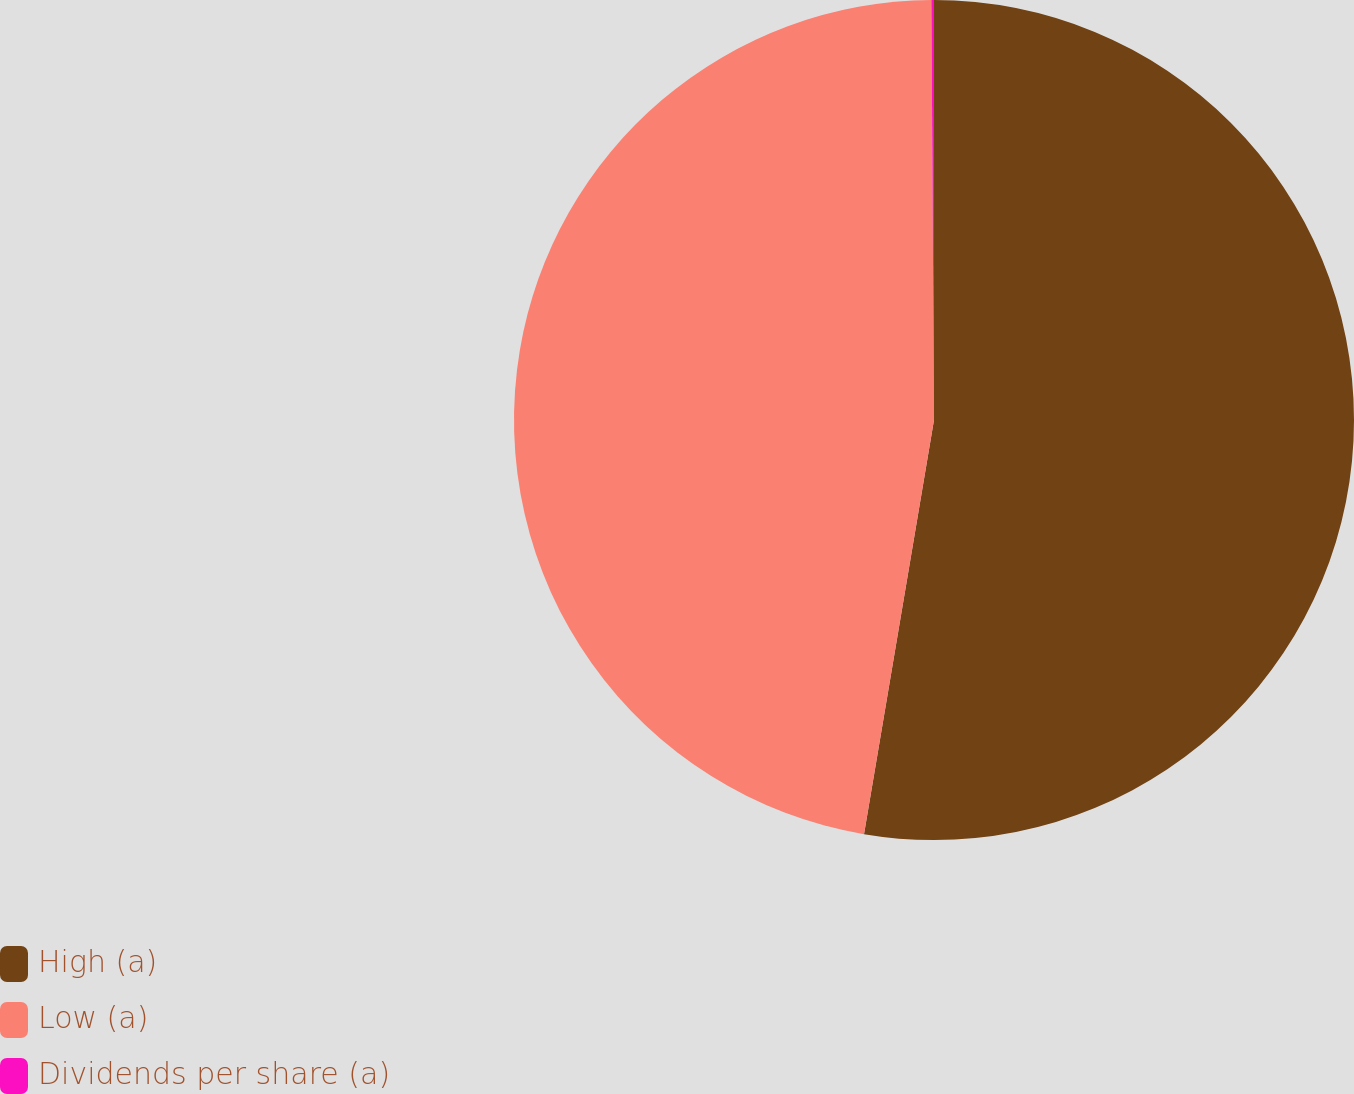Convert chart. <chart><loc_0><loc_0><loc_500><loc_500><pie_chart><fcel>High (a)<fcel>Low (a)<fcel>Dividends per share (a)<nl><fcel>52.67%<fcel>47.24%<fcel>0.1%<nl></chart> 